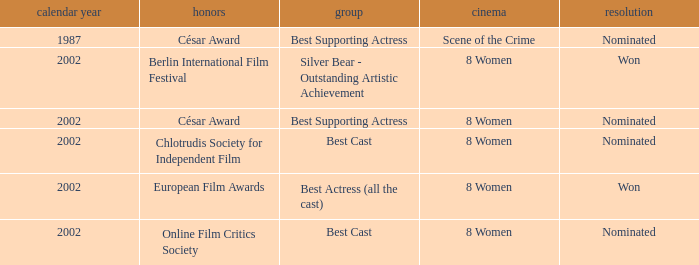In what year was the movie 8 women up for a César Award? 2002.0. 